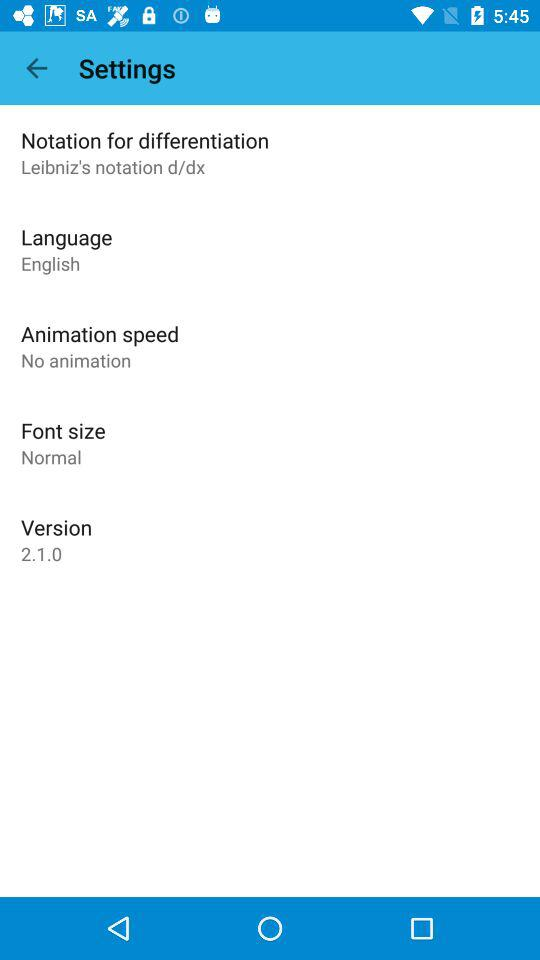What language is used? The language is English. 